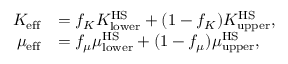<formula> <loc_0><loc_0><loc_500><loc_500>\begin{array} { r l } { K _ { e f f } } & { = f _ { K } K _ { l o w e r } ^ { H S } + ( 1 - f _ { K } ) K _ { u p p e r } ^ { H S } , } \\ { \mu _ { e f f } } & { = f _ { \mu } \mu _ { l o w e r } ^ { H S } + ( 1 - f _ { \mu } ) \mu _ { u p p e r } ^ { H S } , } \end{array}</formula> 